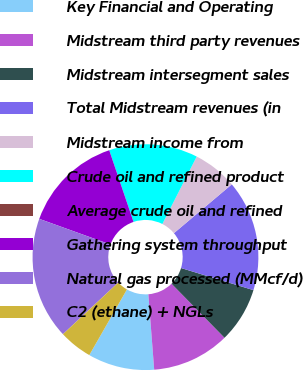Convert chart. <chart><loc_0><loc_0><loc_500><loc_500><pie_chart><fcel>Key Financial and Operating<fcel>Midstream third party revenues<fcel>Midstream intersegment sales<fcel>Total Midstream revenues (in<fcel>Midstream income from<fcel>Crude oil and refined product<fcel>Average crude oil and refined<fcel>Gathering system throughput<fcel>Natural gas processed (MMcf/d)<fcel>C2 (ethane) + NGLs<nl><fcel>9.52%<fcel>11.11%<fcel>7.94%<fcel>15.87%<fcel>6.35%<fcel>12.7%<fcel>0.0%<fcel>14.29%<fcel>17.46%<fcel>4.76%<nl></chart> 